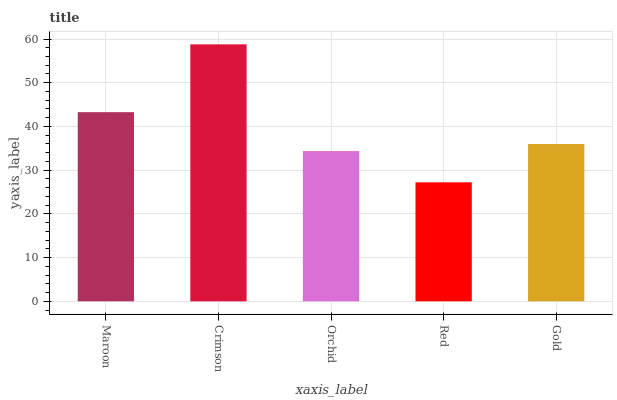Is Red the minimum?
Answer yes or no. Yes. Is Crimson the maximum?
Answer yes or no. Yes. Is Orchid the minimum?
Answer yes or no. No. Is Orchid the maximum?
Answer yes or no. No. Is Crimson greater than Orchid?
Answer yes or no. Yes. Is Orchid less than Crimson?
Answer yes or no. Yes. Is Orchid greater than Crimson?
Answer yes or no. No. Is Crimson less than Orchid?
Answer yes or no. No. Is Gold the high median?
Answer yes or no. Yes. Is Gold the low median?
Answer yes or no. Yes. Is Crimson the high median?
Answer yes or no. No. Is Crimson the low median?
Answer yes or no. No. 